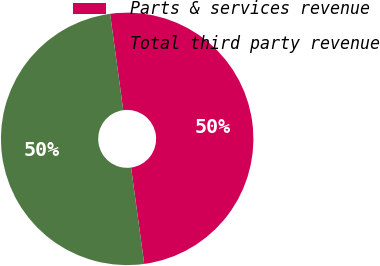<chart> <loc_0><loc_0><loc_500><loc_500><pie_chart><fcel>Parts & services revenue<fcel>Total third party revenue<nl><fcel>50.0%<fcel>50.0%<nl></chart> 